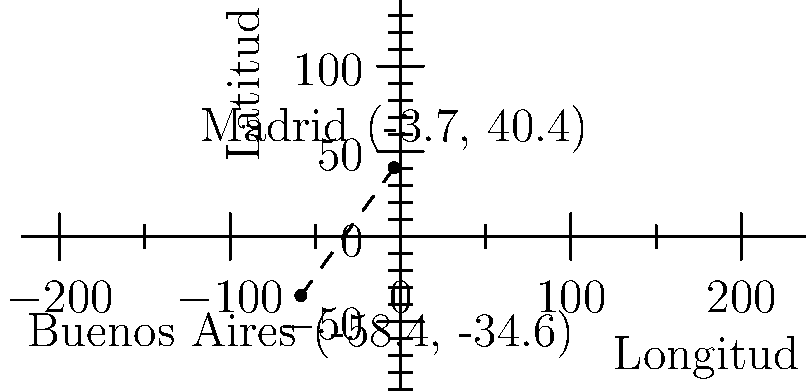En un mapa mundial, Madrid tiene coordenadas (-3.7, 40.4) y Buenos Aires tiene coordenadas (-58.4, -34.6). Si cada unidad en el mapa representa 111 km en la realidad, ¿cuál es la distancia aproximada entre estas dos ciudades? Para calcular la distancia entre Madrid y Buenos Aires, seguiremos estos pasos:

1. Calcular la diferencia en longitud:
   $\Delta x = -58.4 - (-3.7) = -54.7$

2. Calcular la diferencia en latitud:
   $\Delta y = -34.6 - 40.4 = -75$

3. Usar el teorema de Pitágoras para calcular la distancia en unidades del mapa:
   $d = \sqrt{(\Delta x)^2 + (\Delta y)^2}$
   $d = \sqrt{(-54.7)^2 + (-75)^2}$
   $d = \sqrt{2992.09 + 5625}$
   $d = \sqrt{8617.09}$
   $d \approx 92.83$ unidades

4. Convertir la distancia a kilómetros:
   Distancia en km $= 92.83 \times 111 \approx 10,304$ km

Por lo tanto, la distancia aproximada entre Madrid y Buenos Aires es de 10,304 km.
Answer: 10,304 km 